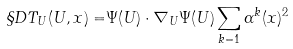Convert formula to latex. <formula><loc_0><loc_0><loc_500><loc_500>\S D T _ { U } ( U , x ) = & \Psi ( U ) \cdot \nabla _ { U } \Psi ( U ) \sum _ { k = 1 } \alpha ^ { k } ( x ) ^ { 2 }</formula> 